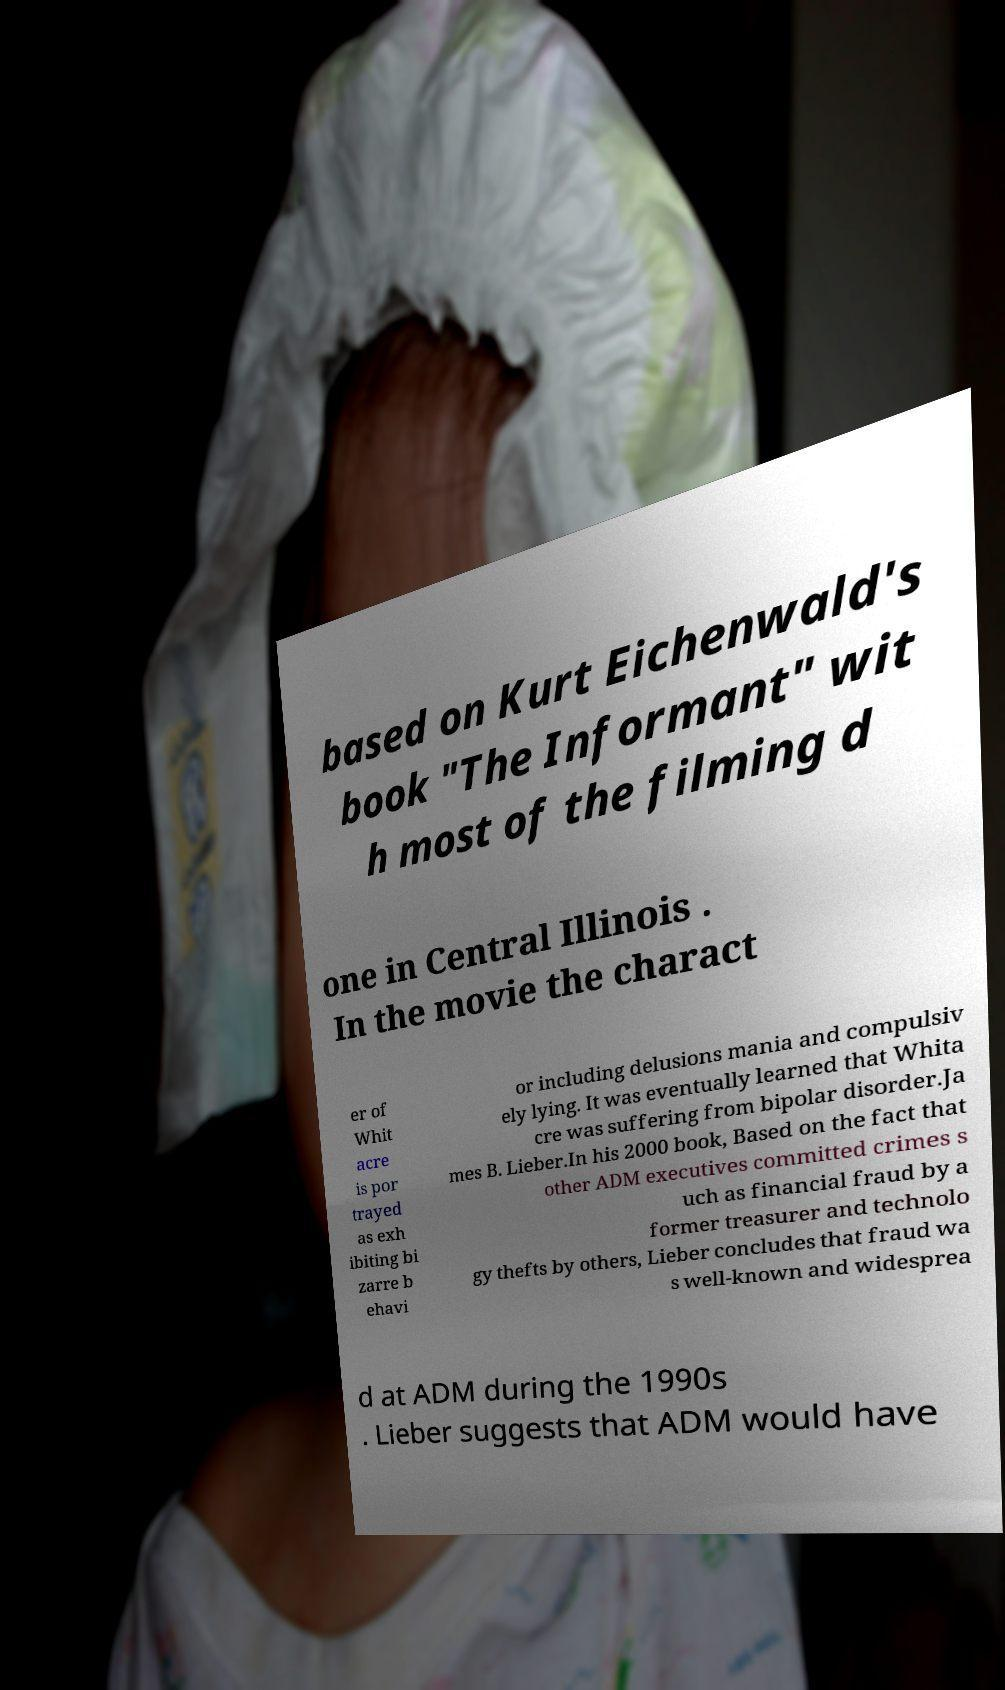Please read and relay the text visible in this image. What does it say? based on Kurt Eichenwald's book "The Informant" wit h most of the filming d one in Central Illinois . In the movie the charact er of Whit acre is por trayed as exh ibiting bi zarre b ehavi or including delusions mania and compulsiv ely lying. It was eventually learned that Whita cre was suffering from bipolar disorder.Ja mes B. Lieber.In his 2000 book, Based on the fact that other ADM executives committed crimes s uch as financial fraud by a former treasurer and technolo gy thefts by others, Lieber concludes that fraud wa s well-known and widesprea d at ADM during the 1990s . Lieber suggests that ADM would have 